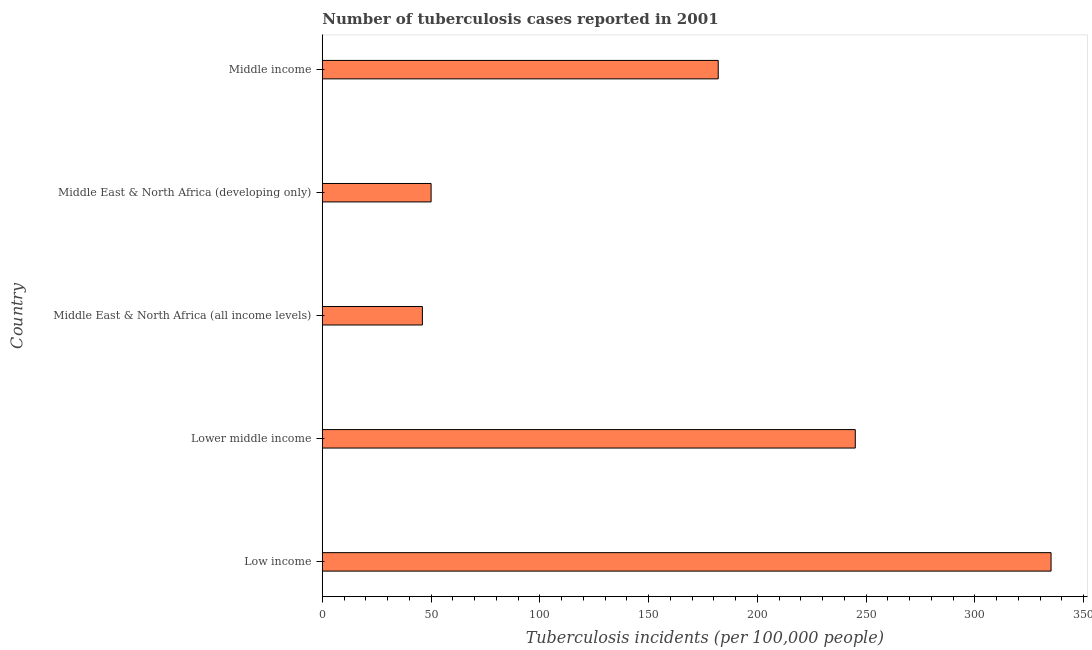Does the graph contain grids?
Your answer should be very brief. No. What is the title of the graph?
Your response must be concise. Number of tuberculosis cases reported in 2001. What is the label or title of the X-axis?
Your response must be concise. Tuberculosis incidents (per 100,0 people). Across all countries, what is the maximum number of tuberculosis incidents?
Make the answer very short. 335. In which country was the number of tuberculosis incidents minimum?
Your response must be concise. Middle East & North Africa (all income levels). What is the sum of the number of tuberculosis incidents?
Offer a terse response. 858. What is the difference between the number of tuberculosis incidents in Middle East & North Africa (developing only) and Middle income?
Offer a very short reply. -132. What is the average number of tuberculosis incidents per country?
Give a very brief answer. 171.6. What is the median number of tuberculosis incidents?
Keep it short and to the point. 182. In how many countries, is the number of tuberculosis incidents greater than 90 ?
Keep it short and to the point. 3. What is the ratio of the number of tuberculosis incidents in Low income to that in Middle income?
Make the answer very short. 1.84. Is the number of tuberculosis incidents in Lower middle income less than that in Middle income?
Make the answer very short. No. Is the difference between the number of tuberculosis incidents in Low income and Middle income greater than the difference between any two countries?
Provide a succinct answer. No. Is the sum of the number of tuberculosis incidents in Middle East & North Africa (all income levels) and Middle income greater than the maximum number of tuberculosis incidents across all countries?
Provide a short and direct response. No. What is the difference between the highest and the lowest number of tuberculosis incidents?
Provide a short and direct response. 289. How many countries are there in the graph?
Make the answer very short. 5. What is the difference between two consecutive major ticks on the X-axis?
Your response must be concise. 50. Are the values on the major ticks of X-axis written in scientific E-notation?
Offer a terse response. No. What is the Tuberculosis incidents (per 100,000 people) in Low income?
Make the answer very short. 335. What is the Tuberculosis incidents (per 100,000 people) in Lower middle income?
Provide a short and direct response. 245. What is the Tuberculosis incidents (per 100,000 people) of Middle East & North Africa (all income levels)?
Offer a very short reply. 46. What is the Tuberculosis incidents (per 100,000 people) in Middle East & North Africa (developing only)?
Offer a very short reply. 50. What is the Tuberculosis incidents (per 100,000 people) of Middle income?
Offer a terse response. 182. What is the difference between the Tuberculosis incidents (per 100,000 people) in Low income and Lower middle income?
Ensure brevity in your answer.  90. What is the difference between the Tuberculosis incidents (per 100,000 people) in Low income and Middle East & North Africa (all income levels)?
Your response must be concise. 289. What is the difference between the Tuberculosis incidents (per 100,000 people) in Low income and Middle East & North Africa (developing only)?
Your response must be concise. 285. What is the difference between the Tuberculosis incidents (per 100,000 people) in Low income and Middle income?
Give a very brief answer. 153. What is the difference between the Tuberculosis incidents (per 100,000 people) in Lower middle income and Middle East & North Africa (all income levels)?
Offer a very short reply. 199. What is the difference between the Tuberculosis incidents (per 100,000 people) in Lower middle income and Middle East & North Africa (developing only)?
Ensure brevity in your answer.  195. What is the difference between the Tuberculosis incidents (per 100,000 people) in Lower middle income and Middle income?
Your response must be concise. 63. What is the difference between the Tuberculosis incidents (per 100,000 people) in Middle East & North Africa (all income levels) and Middle income?
Provide a short and direct response. -136. What is the difference between the Tuberculosis incidents (per 100,000 people) in Middle East & North Africa (developing only) and Middle income?
Keep it short and to the point. -132. What is the ratio of the Tuberculosis incidents (per 100,000 people) in Low income to that in Lower middle income?
Offer a very short reply. 1.37. What is the ratio of the Tuberculosis incidents (per 100,000 people) in Low income to that in Middle East & North Africa (all income levels)?
Your answer should be very brief. 7.28. What is the ratio of the Tuberculosis incidents (per 100,000 people) in Low income to that in Middle East & North Africa (developing only)?
Offer a terse response. 6.7. What is the ratio of the Tuberculosis incidents (per 100,000 people) in Low income to that in Middle income?
Offer a terse response. 1.84. What is the ratio of the Tuberculosis incidents (per 100,000 people) in Lower middle income to that in Middle East & North Africa (all income levels)?
Your answer should be very brief. 5.33. What is the ratio of the Tuberculosis incidents (per 100,000 people) in Lower middle income to that in Middle East & North Africa (developing only)?
Ensure brevity in your answer.  4.9. What is the ratio of the Tuberculosis incidents (per 100,000 people) in Lower middle income to that in Middle income?
Make the answer very short. 1.35. What is the ratio of the Tuberculosis incidents (per 100,000 people) in Middle East & North Africa (all income levels) to that in Middle income?
Ensure brevity in your answer.  0.25. What is the ratio of the Tuberculosis incidents (per 100,000 people) in Middle East & North Africa (developing only) to that in Middle income?
Offer a very short reply. 0.28. 